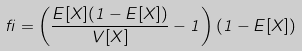Convert formula to latex. <formula><loc_0><loc_0><loc_500><loc_500>\beta = \left ( { \frac { E [ X ] ( 1 - E [ X ] ) } { V [ X ] } } - 1 \right ) ( 1 - E [ X ] )</formula> 